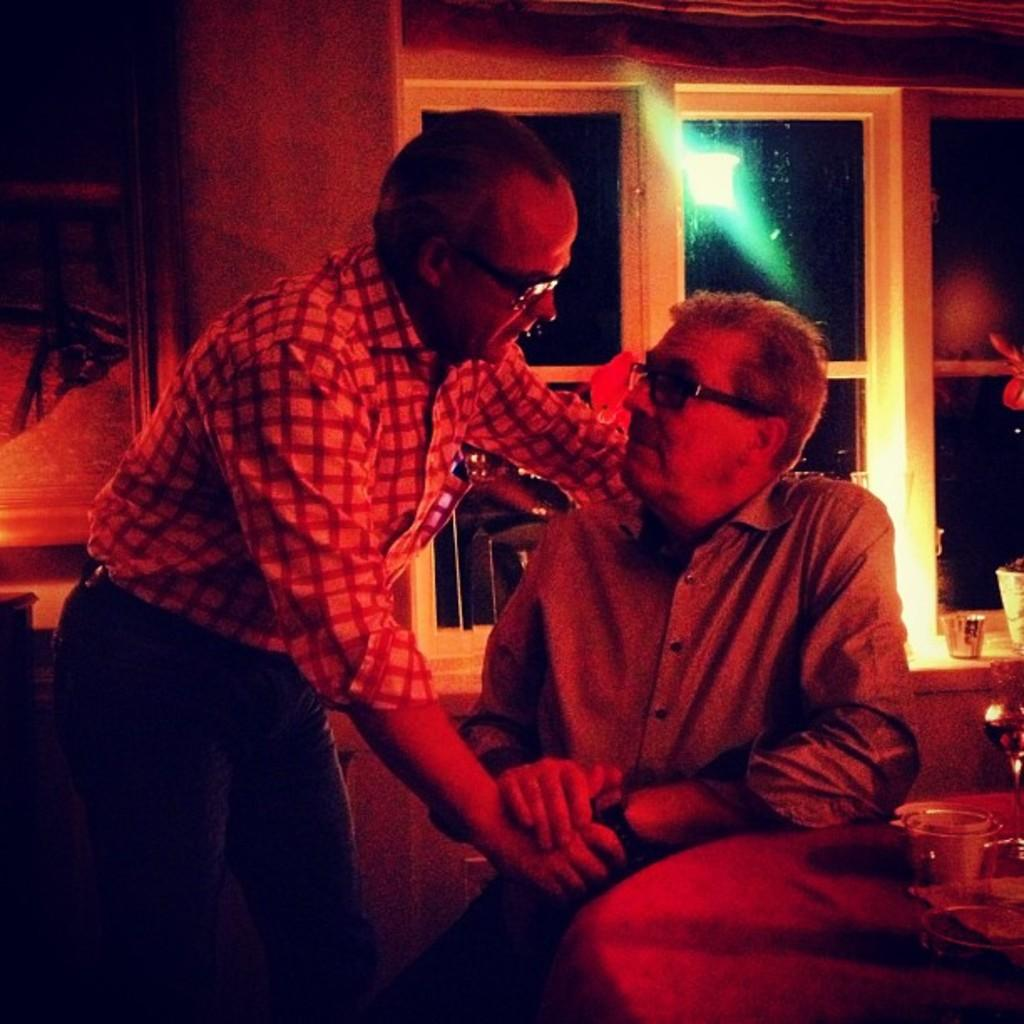How many people are in the image? There are two persons in the image. What is the position of the person on the right? The person on the right is sitting on a chair. What is the position of the person on the left? The person on the left is standing. What can be seen in the background of the image? There are glass windows visible in the background of the image. What type of drink is the person on the right holding in the image? There is no drink visible in the image, and neither person is holding anything. 